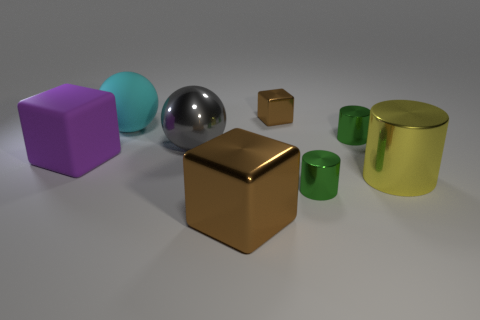Subtract all green cylinders. How many were subtracted if there are1green cylinders left? 1 Add 1 cyan objects. How many objects exist? 9 Subtract all balls. How many objects are left? 6 Subtract all small purple blocks. Subtract all small things. How many objects are left? 5 Add 4 large brown metal objects. How many large brown metal objects are left? 5 Add 8 large blue matte spheres. How many large blue matte spheres exist? 8 Subtract 0 cyan blocks. How many objects are left? 8 